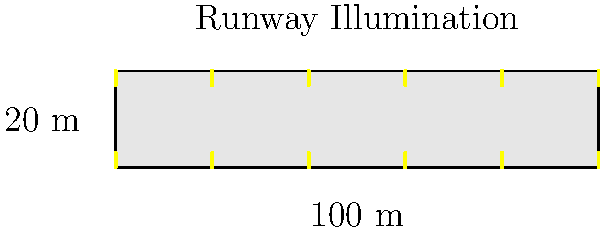As a runway model, you're now working on a project to illuminate an indoor fashion runway. Given a runway that is 100 meters long and 20 meters wide, and knowing that the required illumination level for fashion shows is 1000 lux, calculate the total lumens needed to properly light the entire runway. Assume a light loss factor of 0.8 and a coefficient of utilization of 0.7. To calculate the total lumens needed for the runway, we'll follow these steps:

1. Calculate the area of the runway:
   Area = Length × Width
   $A = 100 \text{ m} \times 20 \text{ m} = 2000 \text{ m}^2$

2. Use the lumen calculation formula:
   $\text{Total Lumens} = \frac{\text{Desired Illumination (lux)} \times \text{Area (m}^2\text{)}}{\text{Light Loss Factor} \times \text{Coefficient of Utilization}}$

3. Plug in the values:
   $\text{Total Lumens} = \frac{1000 \text{ lux} \times 2000 \text{ m}^2}{0.8 \times 0.7}$

4. Perform the calculation:
   $\text{Total Lumens} = \frac{2,000,000}{0.56} = 3,571,428.57 \text{ lumens}$

5. Round to the nearest whole number:
   Total Lumens ≈ 3,571,429 lumens

This calculation ensures that the runway will be properly illuminated for the fashion show, taking into account factors such as light loss and utilization efficiency.
Answer: 3,571,429 lumens 